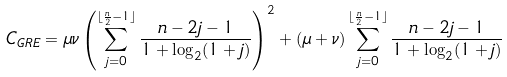Convert formula to latex. <formula><loc_0><loc_0><loc_500><loc_500>C _ { G R E } = \mu \nu \left ( \sum _ { j = 0 } ^ { \lfloor \frac { n } { 2 } - 1 \rfloor } \frac { n - 2 j - 1 } { 1 + \log _ { 2 } ( 1 + j ) } \right ) ^ { 2 } + ( \mu + \nu ) \sum _ { j = 0 } ^ { \lfloor \frac { n } { 2 } - 1 \rfloor } \frac { n - 2 j - 1 } { 1 + \log _ { 2 } ( 1 + j ) }</formula> 